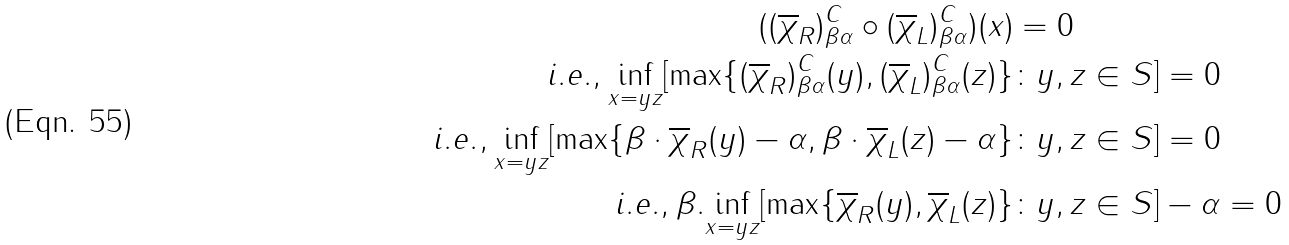Convert formula to latex. <formula><loc_0><loc_0><loc_500><loc_500>( ( \overline { \chi } _ { R } ) _ { \beta \alpha } ^ { C } \circ ( \overline { \chi } _ { L } ) _ { \beta \alpha } ^ { C } ) ( x ) & = 0 \\ i . e . , \underset { x = y z } { \inf } [ \max \{ ( \overline { \chi } _ { R } ) _ { \beta \alpha } ^ { C } ( y ) , ( \overline { \chi } _ { L } ) _ { \beta \alpha } ^ { C } ( z ) \} & \colon y , z \in S ] = 0 \\ i . e . , \underset { x = y z } { \inf } [ \max \{ \beta \cdot \overline { \chi } _ { R } ( y ) - \alpha , \beta \cdot \overline { \chi } _ { L } ( z ) - \alpha \} & \colon y , z \in S ] = 0 \\ i . e . , \beta . \underset { x = y z } { \inf } [ \max \{ \overline { \chi } _ { R } ( y ) , \overline { \chi } _ { L } ( z ) \} & \colon y , z \in S ] - \alpha = 0</formula> 